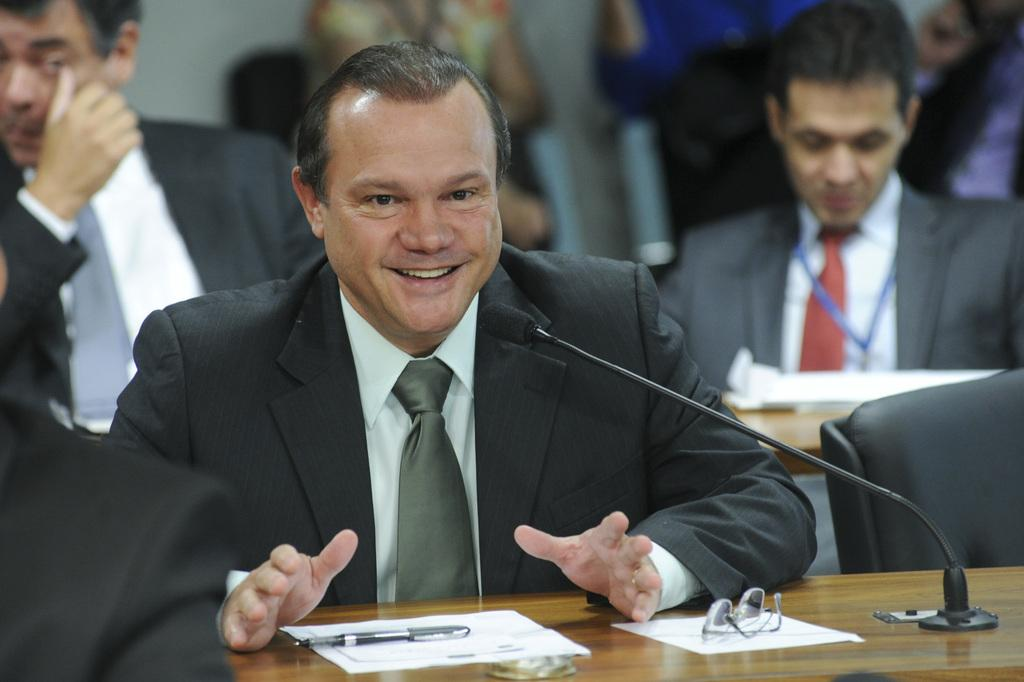What are the people in the image doing? The people in the image are sitting on chairs. What object can be seen on the table in the image? There is a microphone on a table in the image. What type of arch can be seen in the image? There is no arch present in the image. What subject is being taught in the image? There is no teaching or subject being taught in the image. 